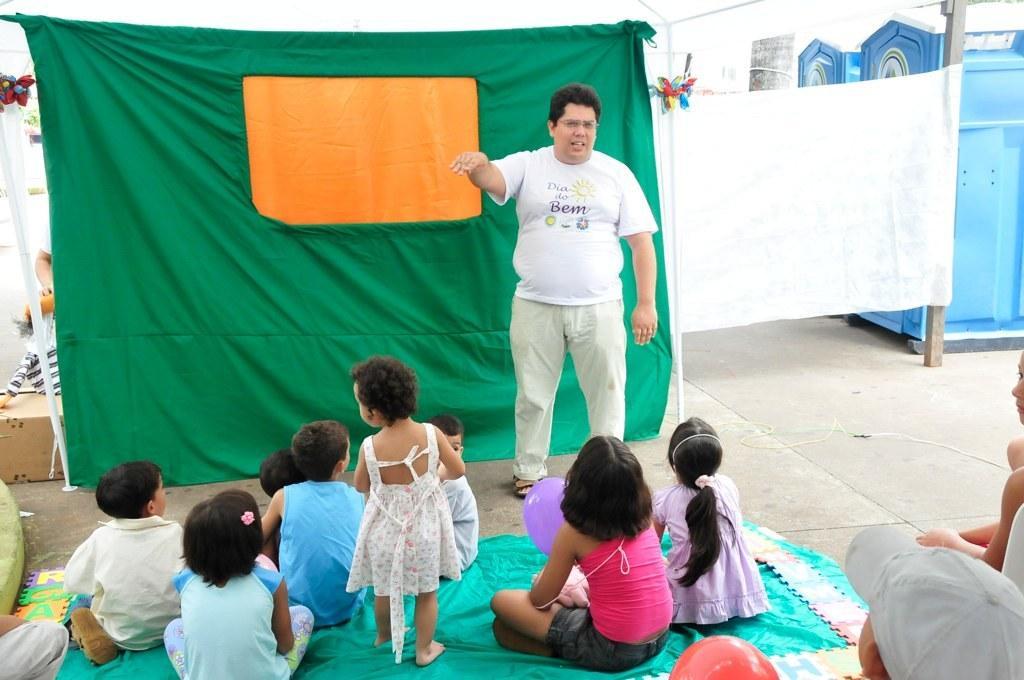Describe this image in one or two sentences. This picture shows few kids seated on the ground on the blanket and we see a girl standing and we see a man standing he wore spectacles on his face and we see a green cloth on the back of him and we see portable toilets on the side and we see box on the floor and we see a boy wore cap on his head and couple of balloons on the floor. 